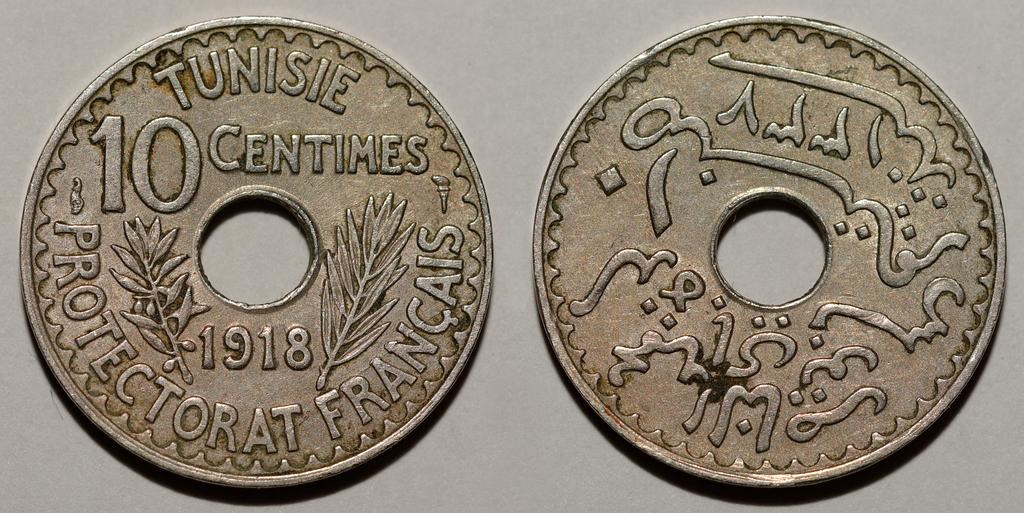<image>
Render a clear and concise summary of the photo. two coins next to each other with holes in them with one of them labeled 'tunisie 10 centimes 1918' on it 